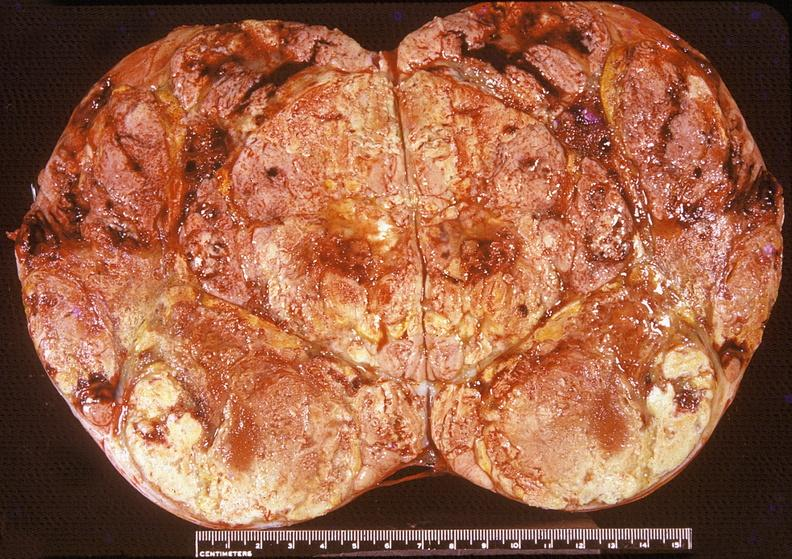does this image show adrenal, cortical carcimoma?
Answer the question using a single word or phrase. Yes 